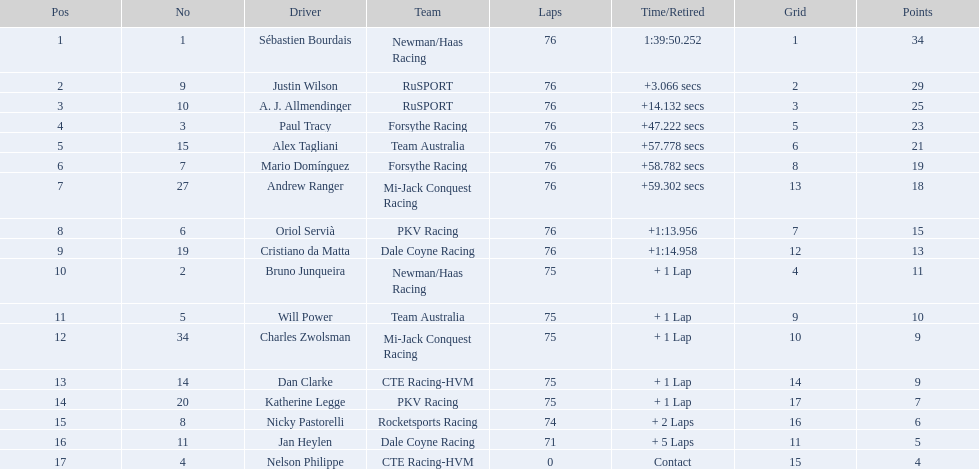Which drivers participated in the 2006 tecate grand prix of monterrey? Sébastien Bourdais, Justin Wilson, A. J. Allmendinger, Paul Tracy, Alex Tagliani, Mario Domínguez, Andrew Ranger, Oriol Servià, Cristiano da Matta, Bruno Junqueira, Will Power, Charles Zwolsman, Dan Clarke, Katherine Legge, Nicky Pastorelli, Jan Heylen, Nelson Philippe. Among them, who had the same number of points as someone else? Charles Zwolsman, Dan Clarke. Who shared the same points with charles zwolsman? Dan Clarke. 